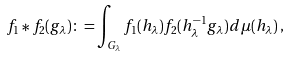<formula> <loc_0><loc_0><loc_500><loc_500>f _ { 1 } \ast f _ { 2 } ( g _ { \lambda } ) \colon = \int _ { G _ { \lambda } } f _ { 1 } ( h _ { \lambda } ) f _ { 2 } ( h _ { \lambda } ^ { - 1 } g _ { \lambda } ) d \mu ( h _ { \lambda } ) \, ,</formula> 